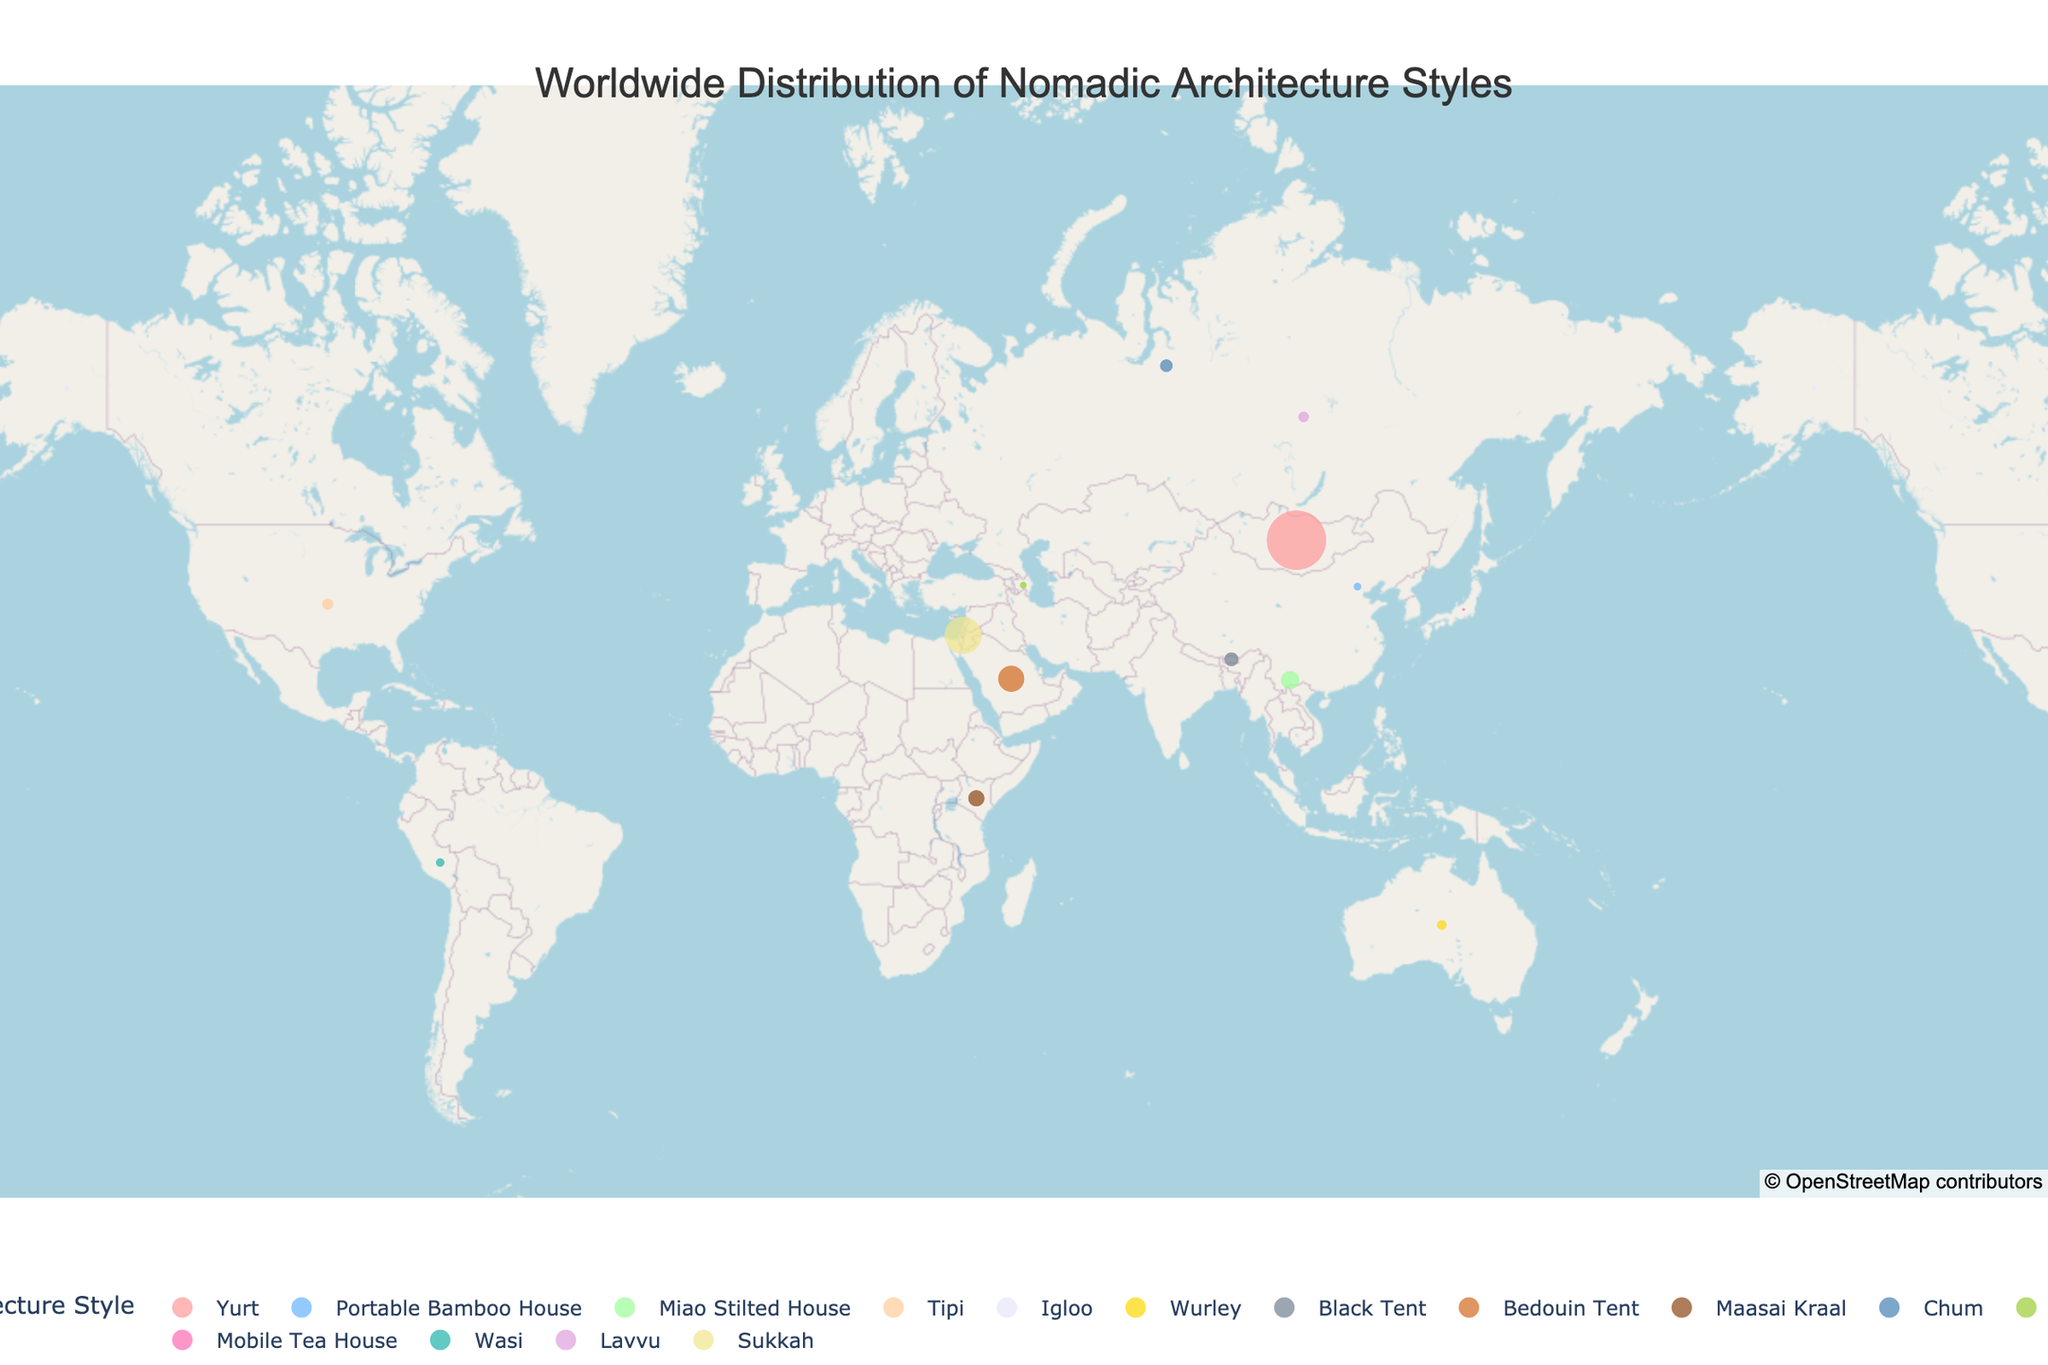What's the title of the plot? The title of the plot is written at the top center of the figure in a larger font. By reading it, we can identify the title.
Answer: Worldwide Distribution of Nomadic Architecture Styles Which nomadic architecture style has the largest population? By examining the figure, look for the largest circle as the size of the circle correlates with population. The largest circle is associated with the Yurt style in Mongolia.
Answer: Yurt How many nomadic architecture styles are represented in Asia? First, identify the countries in Asia that have points marked on the map. Then count the distinct styles for these countries. The regions include Mongolia, China, Yunnan, Bhutan, Saudi Arabia, and Azerbaijan. The distinct styles are Yurt, Portable Bamboo House, Miao Stilted House, Black Tent, Bedouin Tent, and Alaçıq.
Answer: 6 Which region has the smallest population for a given nomadic architecture style? To find this, look for the smallest circle on the map. The figure shows the smallest circle in Japan with the Mobile Tea House style.
Answer: Japan Are there more styles of nomadic architecture in the northern or southern hemisphere? Identify which styles fall in the northern hemisphere (above the equator) and which fall in the southern hemisphere. Count each. Northern Hemisphere includes Yurt, Portable Bamboo House, Miao Stilted House, Black Tent, Bedouin Tent, Alaçıq, Igloo, and Sukkah; Southern Hemisphere includes Wurley, Maasai Kraal, and Wasi.
Answer: Northern Hemisphere Which style is located furthest west? Determine the westernmost point by comparing the longitudes of each point. The furthest west point on the map is in Alaska with the Igloo style.
Answer: Igloo What is the total population of nomadic architecture styles in African regions? Locate the points on the map corresponding to African regions and sum their populations. The data shows only Maasai Kraal in Kenya with a population of 40,000.
Answer: 40,000 Between which two styles is the largest population difference? Compare the populations of all styles and identify the two with the largest numerical difference. The highest population is Yurt (500,000) and the second highest is Sukkah (200,000). The difference is 500,000 - 200,000 = 300,000.
Answer: Yurt and Sukkah 